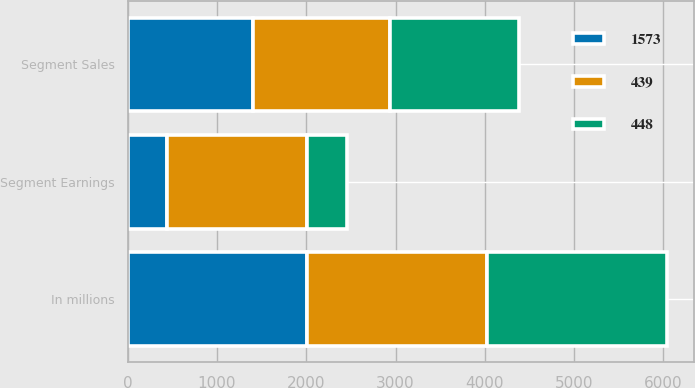<chart> <loc_0><loc_0><loc_500><loc_500><stacked_bar_chart><ecel><fcel>In millions<fcel>Segment Sales<fcel>Segment Earnings<nl><fcel>439<fcel>2013<fcel>1538<fcel>1573<nl><fcel>1573<fcel>2012<fcel>1399<fcel>439<nl><fcel>448<fcel>2011<fcel>1447<fcel>448<nl></chart> 